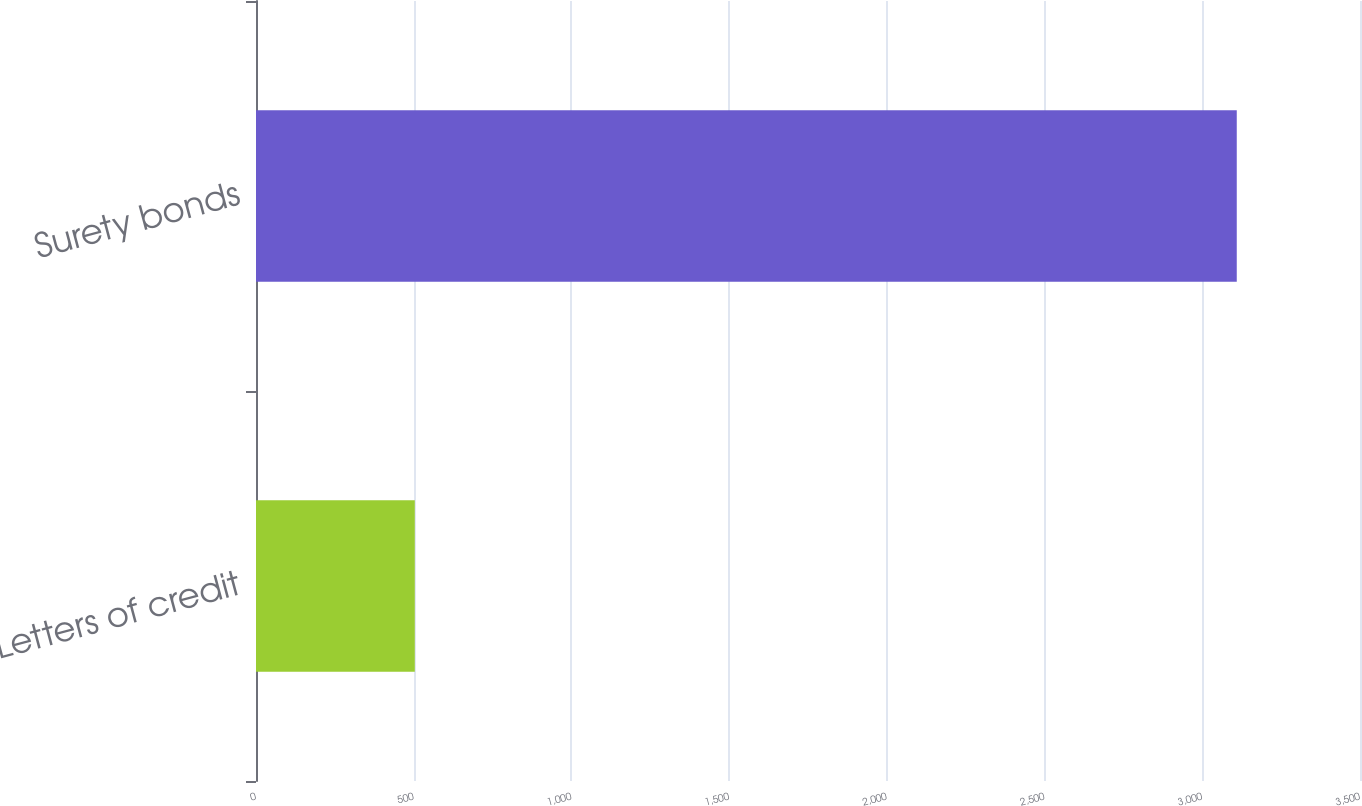<chart> <loc_0><loc_0><loc_500><loc_500><bar_chart><fcel>Letters of credit<fcel>Surety bonds<nl><fcel>503.4<fcel>3109.3<nl></chart> 